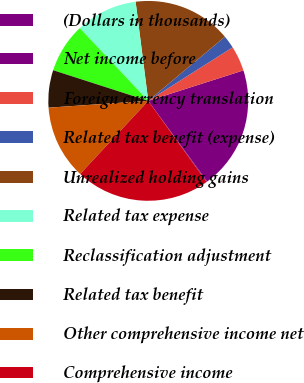Convert chart. <chart><loc_0><loc_0><loc_500><loc_500><pie_chart><fcel>(Dollars in thousands)<fcel>Net income before<fcel>Foreign currency translation<fcel>Related tax benefit (expense)<fcel>Unrealized holding gains<fcel>Related tax expense<fcel>Reclassification adjustment<fcel>Related tax benefit<fcel>Other comprehensive income net<fcel>Comprehensive income<nl><fcel>0.12%<fcel>19.88%<fcel>4.07%<fcel>2.09%<fcel>15.93%<fcel>10.0%<fcel>8.02%<fcel>6.05%<fcel>11.98%<fcel>21.86%<nl></chart> 